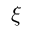<formula> <loc_0><loc_0><loc_500><loc_500>\xi</formula> 